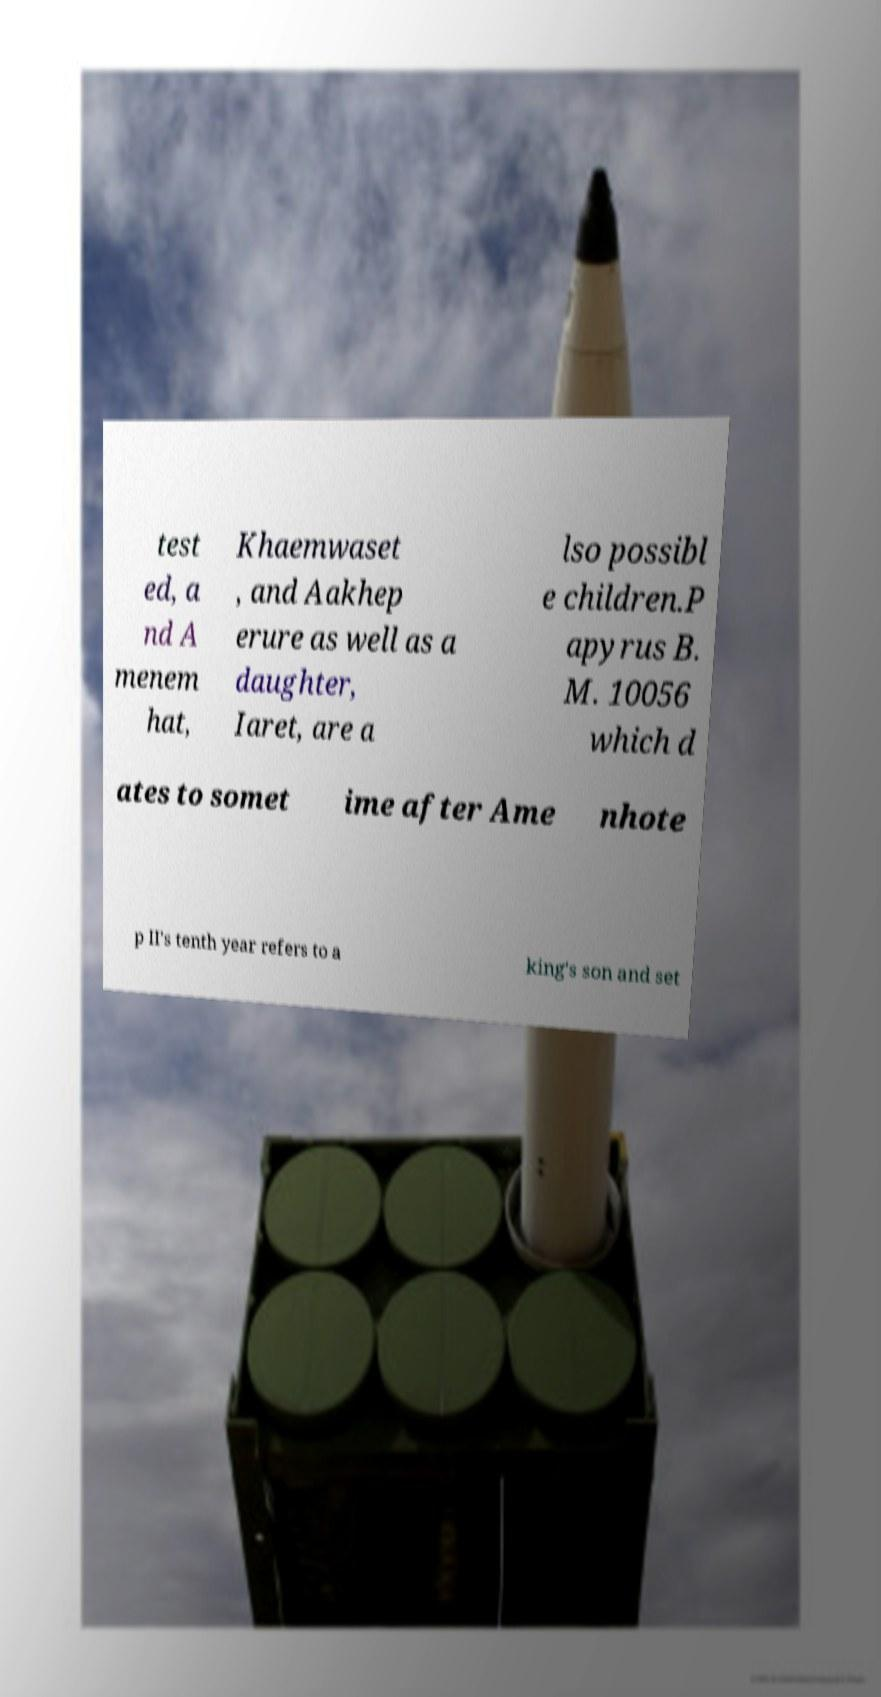There's text embedded in this image that I need extracted. Can you transcribe it verbatim? test ed, a nd A menem hat, Khaemwaset , and Aakhep erure as well as a daughter, Iaret, are a lso possibl e children.P apyrus B. M. 10056 which d ates to somet ime after Ame nhote p II's tenth year refers to a king's son and set 